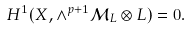<formula> <loc_0><loc_0><loc_500><loc_500>H ^ { 1 } ( X , \wedge ^ { p + 1 } \mathcal { M } _ { L } \otimes L ) = 0 .</formula> 